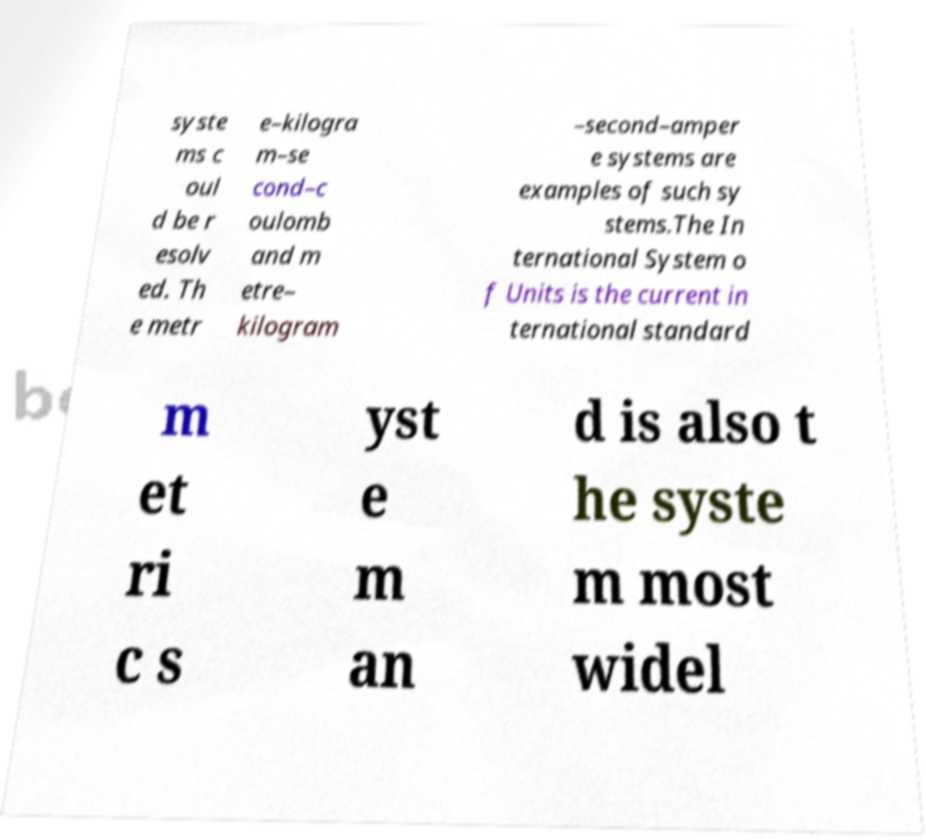Please read and relay the text visible in this image. What does it say? syste ms c oul d be r esolv ed. Th e metr e–kilogra m–se cond–c oulomb and m etre– kilogram –second–amper e systems are examples of such sy stems.The In ternational System o f Units is the current in ternational standard m et ri c s yst e m an d is also t he syste m most widel 